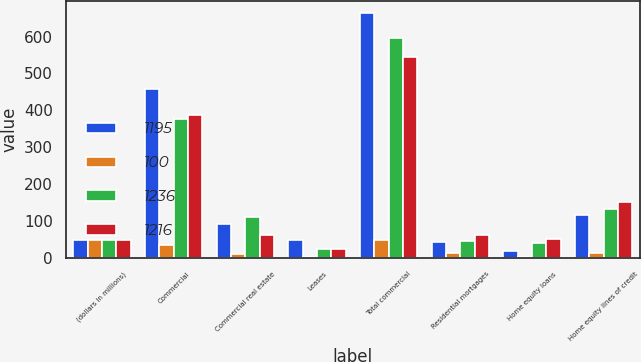Convert chart to OTSL. <chart><loc_0><loc_0><loc_500><loc_500><stacked_bar_chart><ecel><fcel>(dollars in millions)<fcel>Commercial<fcel>Commercial real estate<fcel>Leases<fcel>Total commercial<fcel>Residential mortgages<fcel>Home equity loans<fcel>Home equity lines of credit<nl><fcel>1195<fcel>49<fcel>458<fcel>92<fcel>48<fcel>663<fcel>42<fcel>19<fcel>116<nl><fcel>100<fcel>49<fcel>35<fcel>10<fcel>3<fcel>48<fcel>14<fcel>2<fcel>13<nl><fcel>1236<fcel>49<fcel>376<fcel>111<fcel>23<fcel>596<fcel>46<fcel>39<fcel>132<nl><fcel>1216<fcel>49<fcel>388<fcel>61<fcel>23<fcel>544<fcel>63<fcel>50<fcel>152<nl></chart> 